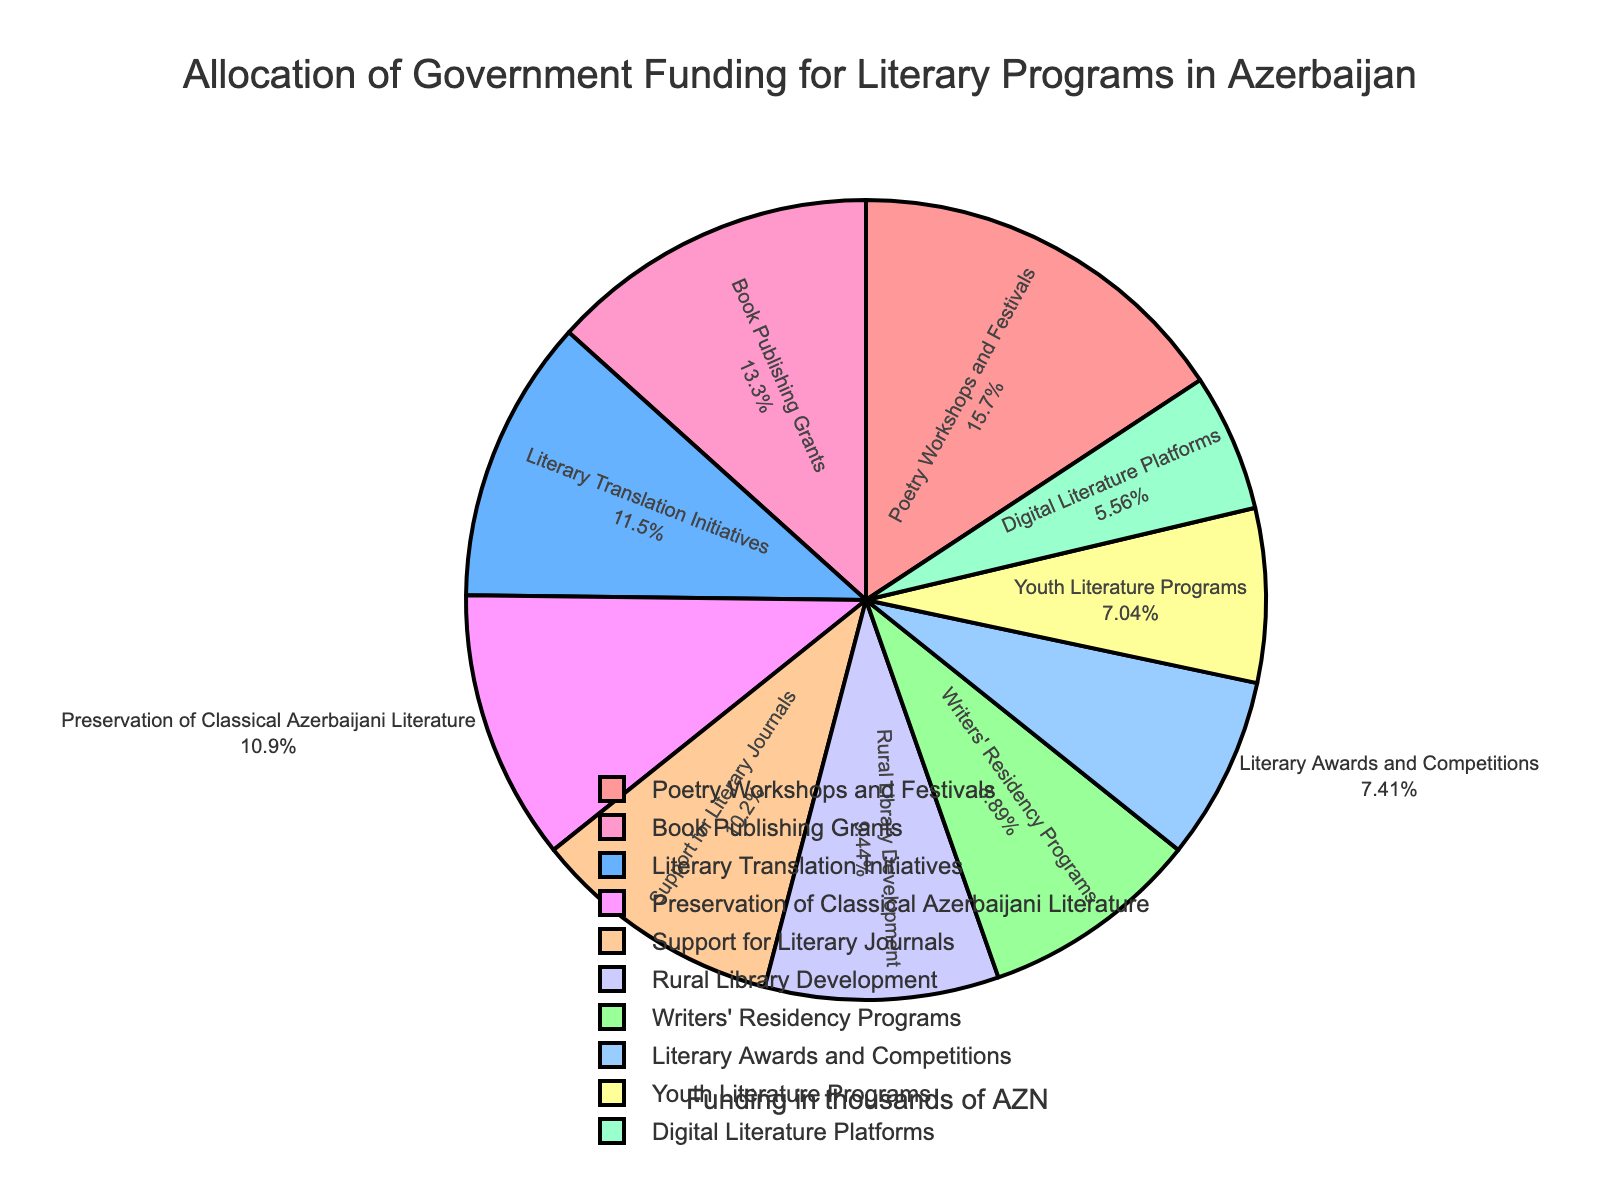What percentage of the funding is allocated to the Poetry Workshops and Festivals? To answer this, look at the pie chart slice labeled "Poetry Workshops and Festivals" which will show the percentage.
Answer: 18.8% Which category receives the least amount of funding? Identify the smallest slice in the pie chart and refer to the label corresponding to it.
Answer: Digital Literature Platforms How much more funding do Book Publishing Grants receive compared to Youth Literature Programs? First, note the amounts for both categories: Book Publishing Grants (720 thousand AZN) and Youth Literature Programs (380 thousand AZN). Then subtract the latter from the former (720 - 380 = 340).
Answer: 340 thousand AZN What is the total funding allocated to Literary Translation Initiatives and Digital Literature Platforms combined? Note the amounts for Literary Translation Initiatives (620 thousand AZN) and Digital Literature Platforms (300 thousand AZN). Add them together (620 + 300 = 920).
Answer: 920 thousand AZN Is the funding for Writers' Residency Programs more or less than the funding for Rural Library Development? Note the amounts for Writers' Residency Programs (480 thousand AZN) and Rural Library Development (510 thousand AZN). Compare the two amounts: 480 is less than 510.
Answer: Less How does the funding for Preservation of Classical Azerbaijani Literature compare to Support for Literary Journals? Note the amounts for Preservation of Classical Azerbaijani Literature (590 thousand AZN) and Support for Literary Journals (550 thousand AZN). Compare the two amounts: 590 is greater than 550.
Answer: Greater What are the three categories with the highest funding? Observe the pie chart and identify the three largest slices. Check the corresponding labels: Poetry Workshops and Festivals (850 thousand AZN), Book Publishing Grants (720 thousand AZN), and Literary Translation Initiatives (620 thousand AZN).
Answer: Poetry Workshops and Festivals, Book Publishing Grants, Literary Translation Initiatives What fraction of the total funding is allocated to Literary Awards and Competitions? Note the total funding (5500 thousand AZN from adding all categories). The funding for Literary Awards and Competitions is 400 thousand AZN. The fraction is 400/5500, which simplifies to approximately 0.073 (or 7.3%).
Answer: 0.073 (or 7.3%) Which categories have more than 600 thousand AZN in funding? Identify the slices in the pie chart whose values exceed 600 thousand AZN and refer to their labels: Poetry Workshops and Festivals (850 thousand AZN), Book Publishing Grants (720 thousand AZN), and Literary Translation Initiatives (620 thousand AZN).
Answer: Poetry Workshops and Festivals, Book Publishing Grants, Literary Translation Initiatives How does the funding for Youth Literature Programs and Literary Awards and Competitions combined compare to the funding for Book Publishing Grants? Note the amounts for Youth Literature Programs (380 thousand AZN) and Literary Awards and Competitions (400 thousand AZN). Sum them up (380 + 400 = 780). Then compare this to Book Publishing Grants (720 thousand AZN). 780 is more than 720.
Answer: More 